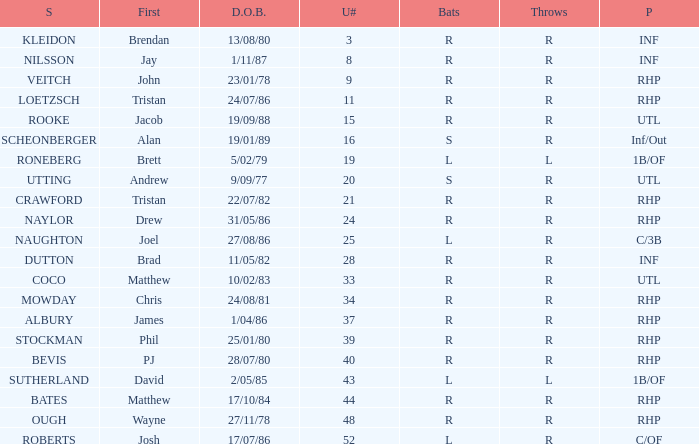Which Position has a Surname of naylor? RHP. Parse the full table. {'header': ['S', 'First', 'D.O.B.', 'U#', 'Bats', 'Throws', 'P'], 'rows': [['KLEIDON', 'Brendan', '13/08/80', '3', 'R', 'R', 'INF'], ['NILSSON', 'Jay', '1/11/87', '8', 'R', 'R', 'INF'], ['VEITCH', 'John', '23/01/78', '9', 'R', 'R', 'RHP'], ['LOETZSCH', 'Tristan', '24/07/86', '11', 'R', 'R', 'RHP'], ['ROOKE', 'Jacob', '19/09/88', '15', 'R', 'R', 'UTL'], ['SCHEONBERGER', 'Alan', '19/01/89', '16', 'S', 'R', 'Inf/Out'], ['RONEBERG', 'Brett', '5/02/79', '19', 'L', 'L', '1B/OF'], ['UTTING', 'Andrew', '9/09/77', '20', 'S', 'R', 'UTL'], ['CRAWFORD', 'Tristan', '22/07/82', '21', 'R', 'R', 'RHP'], ['NAYLOR', 'Drew', '31/05/86', '24', 'R', 'R', 'RHP'], ['NAUGHTON', 'Joel', '27/08/86', '25', 'L', 'R', 'C/3B'], ['DUTTON', 'Brad', '11/05/82', '28', 'R', 'R', 'INF'], ['COCO', 'Matthew', '10/02/83', '33', 'R', 'R', 'UTL'], ['MOWDAY', 'Chris', '24/08/81', '34', 'R', 'R', 'RHP'], ['ALBURY', 'James', '1/04/86', '37', 'R', 'R', 'RHP'], ['STOCKMAN', 'Phil', '25/01/80', '39', 'R', 'R', 'RHP'], ['BEVIS', 'PJ', '28/07/80', '40', 'R', 'R', 'RHP'], ['SUTHERLAND', 'David', '2/05/85', '43', 'L', 'L', '1B/OF'], ['BATES', 'Matthew', '17/10/84', '44', 'R', 'R', 'RHP'], ['OUGH', 'Wayne', '27/11/78', '48', 'R', 'R', 'RHP'], ['ROBERTS', 'Josh', '17/07/86', '52', 'L', 'R', 'C/OF']]} 